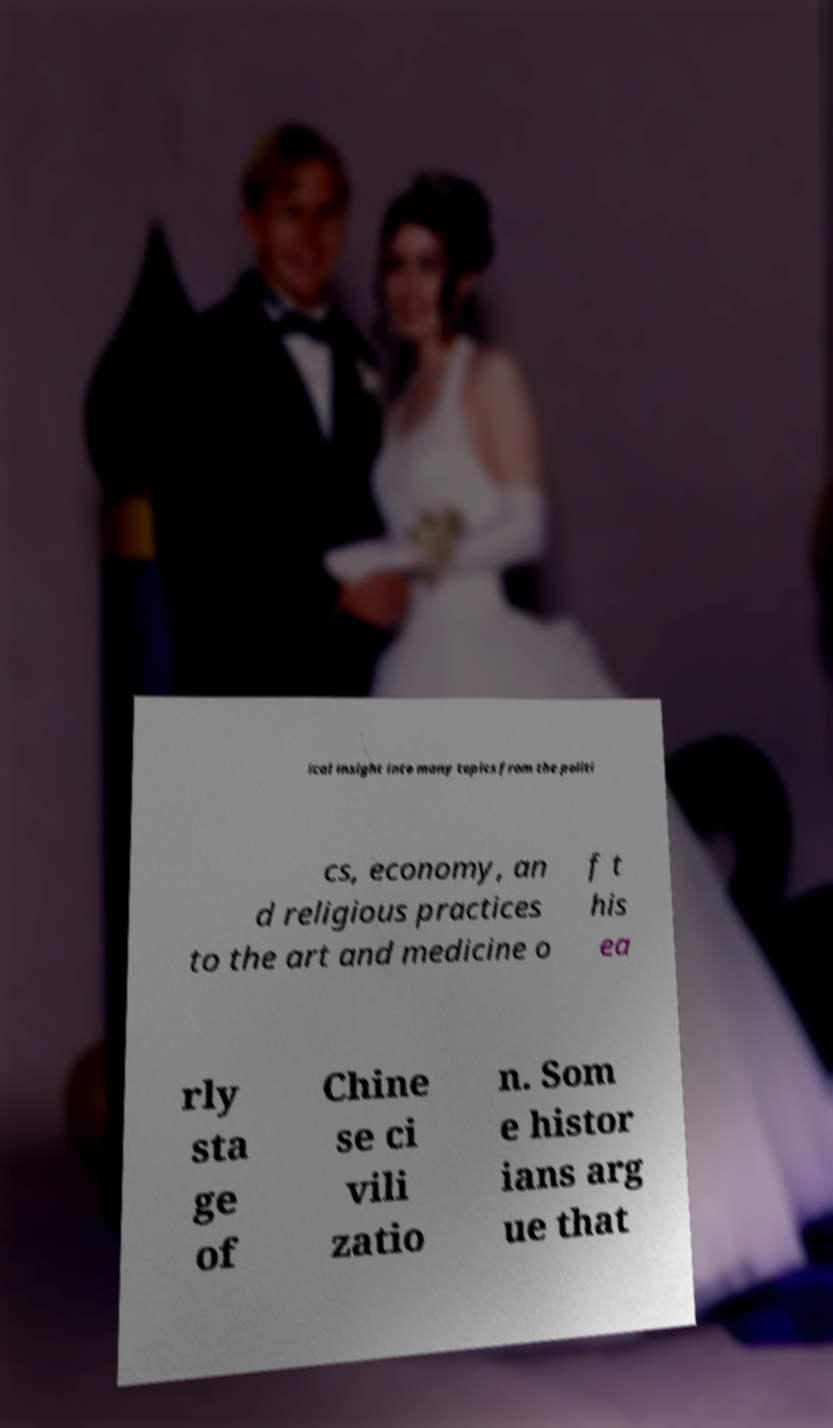Could you extract and type out the text from this image? ical insight into many topics from the politi cs, economy, an d religious practices to the art and medicine o f t his ea rly sta ge of Chine se ci vili zatio n. Som e histor ians arg ue that 